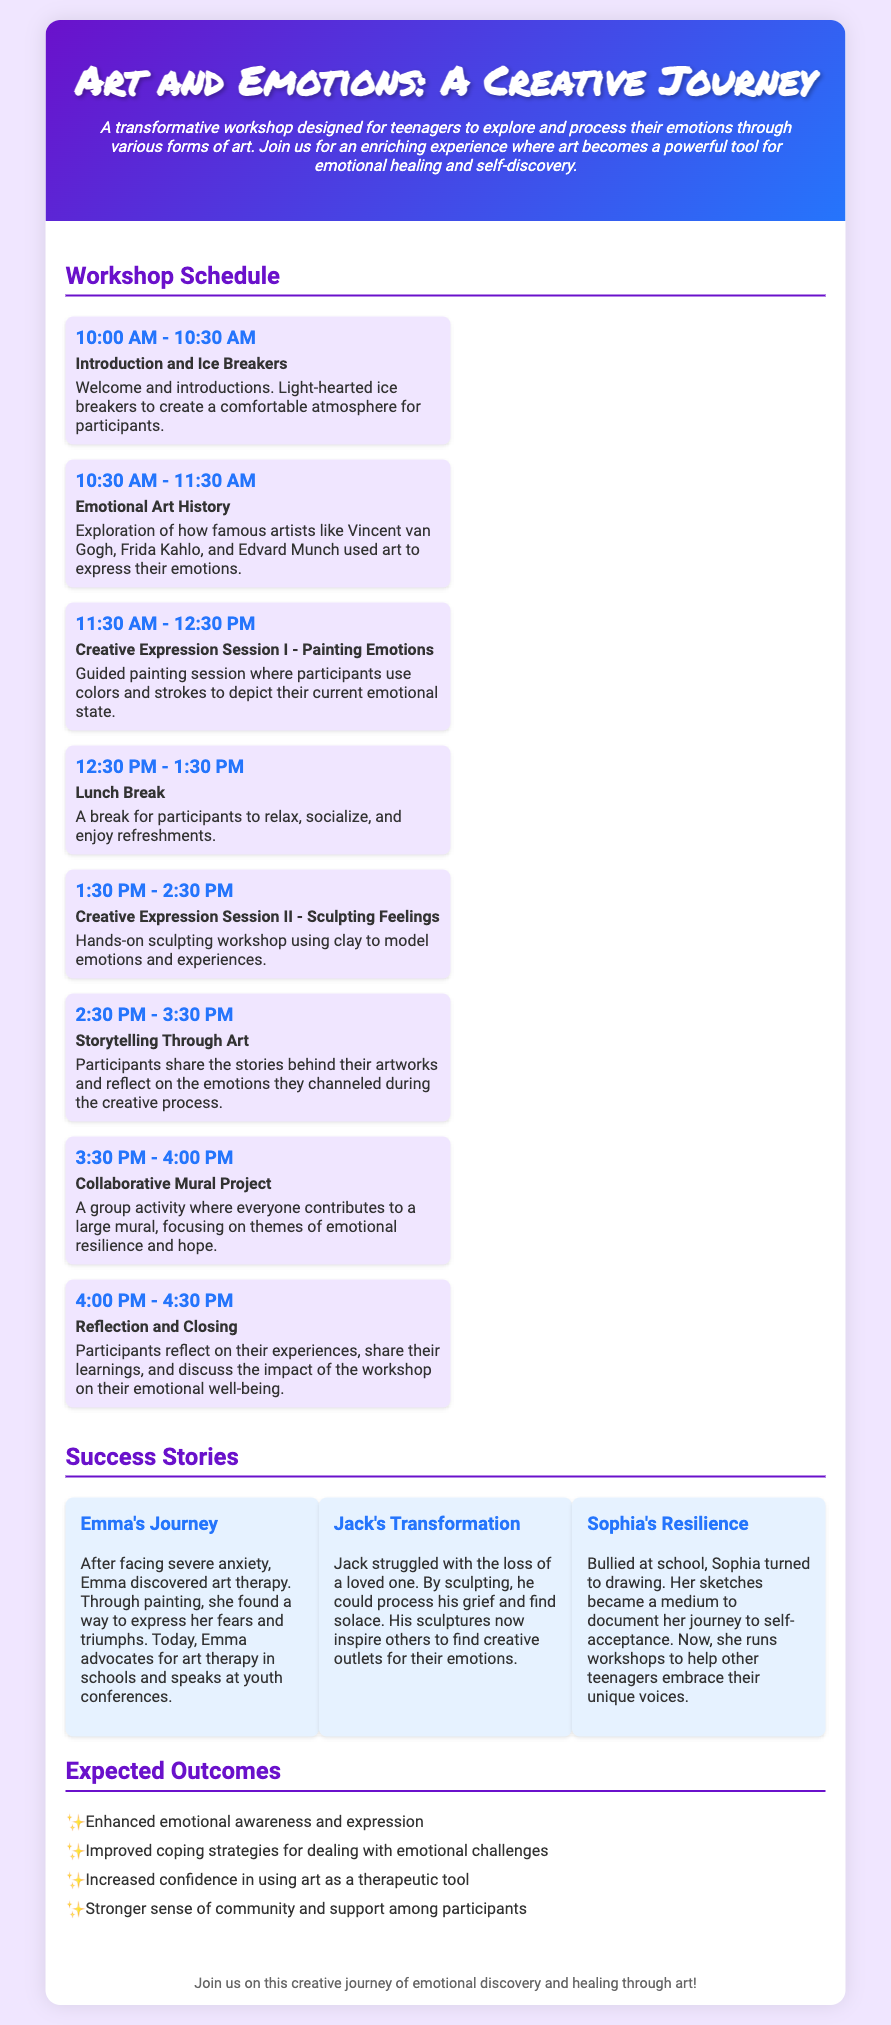what time does the workshop start? The workshop schedule lists the start time as the first item, which is 10:00 AM.
Answer: 10:00 AM who is the first speaker in the workshop? The introduction and ice breakers session does not mention a specific speaker, focusing instead on welcoming participants.
Answer: No specific speaker what activity is scheduled from 1:30 PM to 2:30 PM? The schedule indicates that a hands-on sculpting workshop is planned during this time, titled "Creative Expression Session II - Sculpting Feelings".
Answer: Sculpting Feelings what is the main theme of the collaborative mural project? The document specifies that the group activity centers around themes of emotional resilience and hope.
Answer: Emotional resilience and hope how many success stories are featured in the document? The success stories section includes three individual stories highlighting the journeys of participants.
Answer: Three what was Emma's main medium of expression? According to her success story, Emma primarily used painting as her medium to express fears and triumphs.
Answer: Painting which artist is mentioned as an example in the emotional art history session? The workshop highlights several famous artists and specifically mentions Vincent van Gogh as one of the examples.
Answer: Vincent van Gogh what is the duration of the lunch break? The workshop itinerary states that the lunch break lasts for one hour, from 12:30 PM to 1:30 PM.
Answer: One hour what is one expected outcome of the workshop? The expected outcomes section lists several outcomes; one mentioned outcome is enhanced emotional awareness and expression.
Answer: Enhanced emotional awareness and expression 